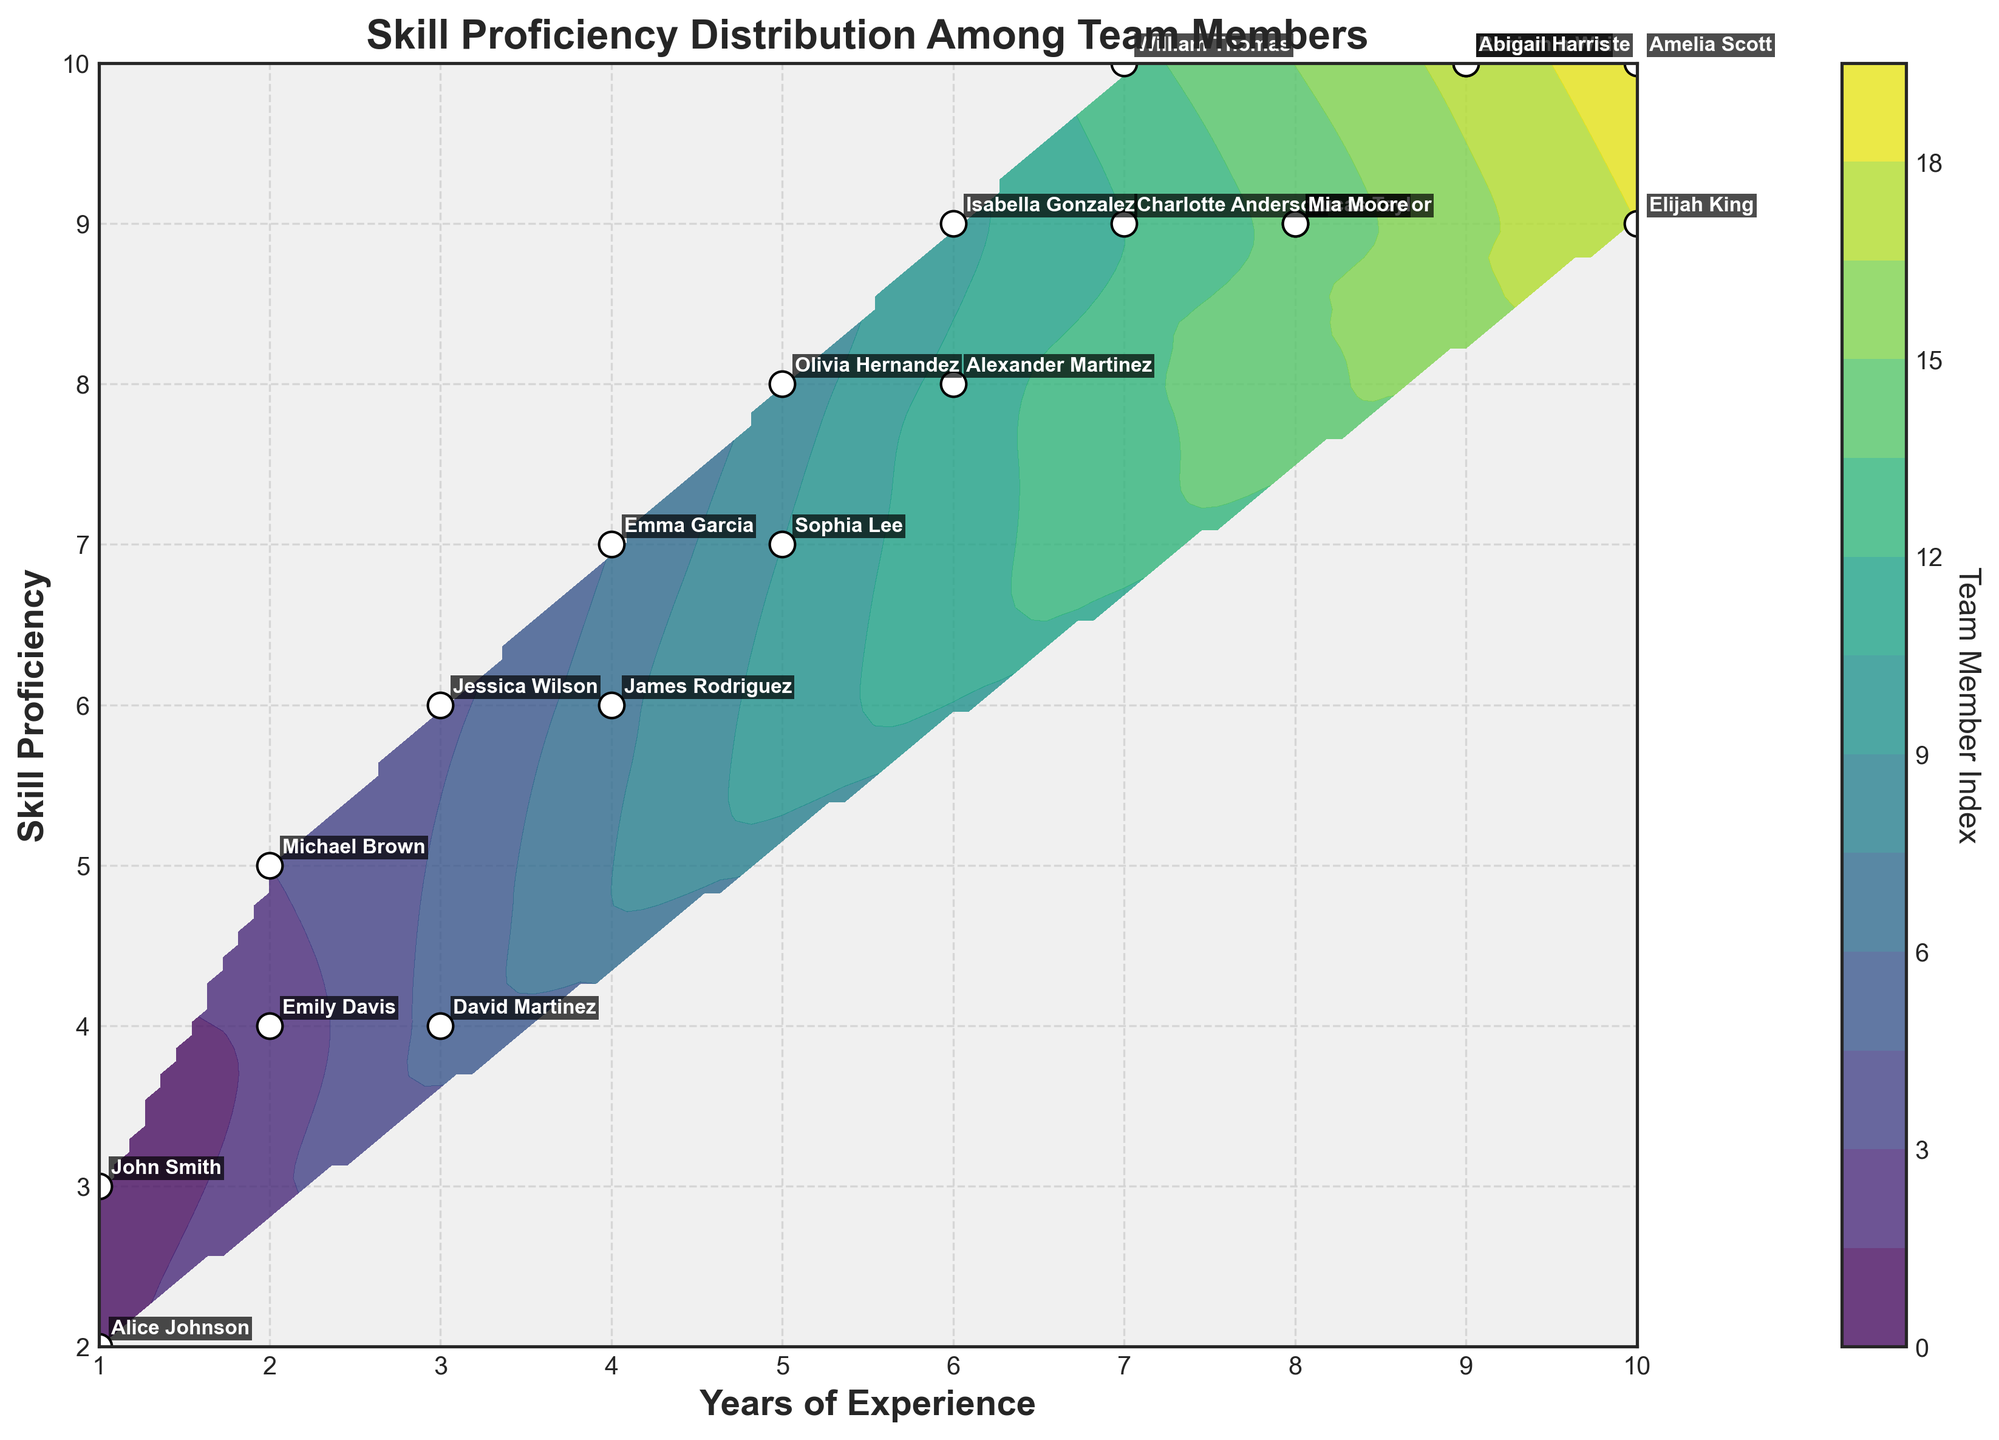What is the title of the figure? The title is located at the top of the figure, using a bold font. It describes what the plot is about.
Answer: Skill Proficiency Distribution Among Team Members How many team members have 10 years of experience? To find this, look along the x-axis for the value 10 and count the number of points plotted vertically from this value.
Answer: 2 Which team member has the highest skill proficiency? Skill proficiency is on the y-axis; find the highest value (10) and look for the corresponding label.
Answer: William Thomas How many team members have a skill proficiency of 9? Look along the y-axis for the value 9 and count the number of data points plotted horizontally from this value.
Answer: 5 Who are the team members with 5 years of experience? Find 5 on the x-axis and check the labels of the points plotted vertically from this value.
Answer: Olivia Hernandez, Sophia Lee What is the average skill proficiency for team members with 7 years of experience? Find 7 on the x-axis, then find the skill proficiency values (9 and 10) for William Thomas and Charlotte Anderson. Calculate the average: (9 + 10)/2.
Answer: 9.5 Is there any team member with both the highest years of experience and the highest skill proficiency? The highest years of experience is 10, and the highest skill proficiency is 10. Identify if the same label appears for both.
Answer: No Compare skill proficiency between John Smith and Alice Johnson. Who has the higher proficiency? Locate both names on the plot and compare the y-values (skill proficiency). John Smith has a proficiency of 3, Alice Johnson has a proficiency of 2.
Answer: John Smith What's the relationship between years of experience and skill proficiency? Observe the general trend of the contour plot. As years of experience increase (move right on x-axis), the skill proficiency seems to generally increase (move up on y-axis).
Answer: Positive correlation Which team member is marked with the highest z-index in the contour plot color bar? Identify the contour levels associated with colors on the color bar, and find the highest value. Check which team member's point is located in the contour area with the highest z-index.
Answer: Amelia Scott 